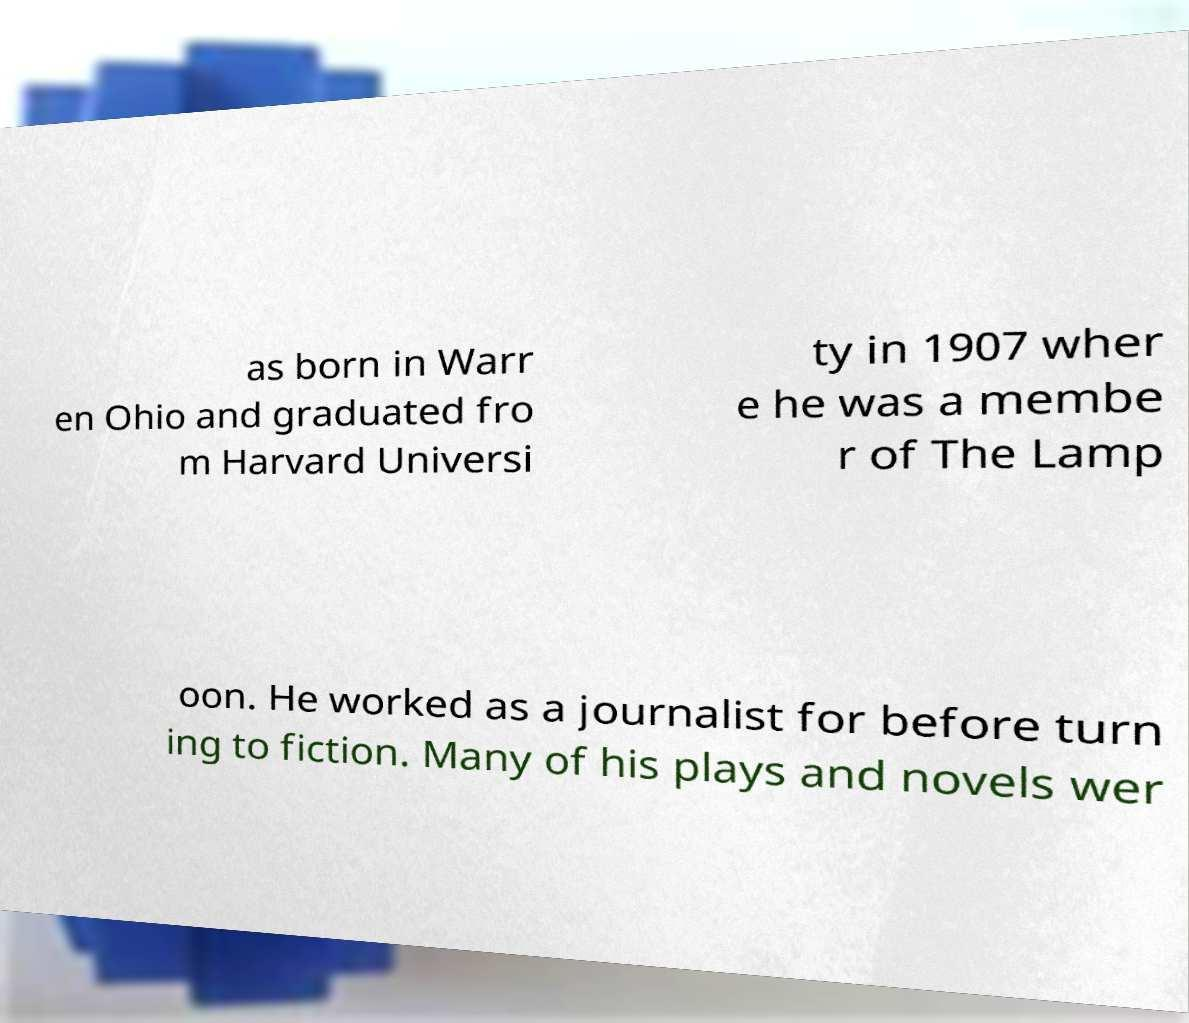Can you accurately transcribe the text from the provided image for me? as born in Warr en Ohio and graduated fro m Harvard Universi ty in 1907 wher e he was a membe r of The Lamp oon. He worked as a journalist for before turn ing to fiction. Many of his plays and novels wer 